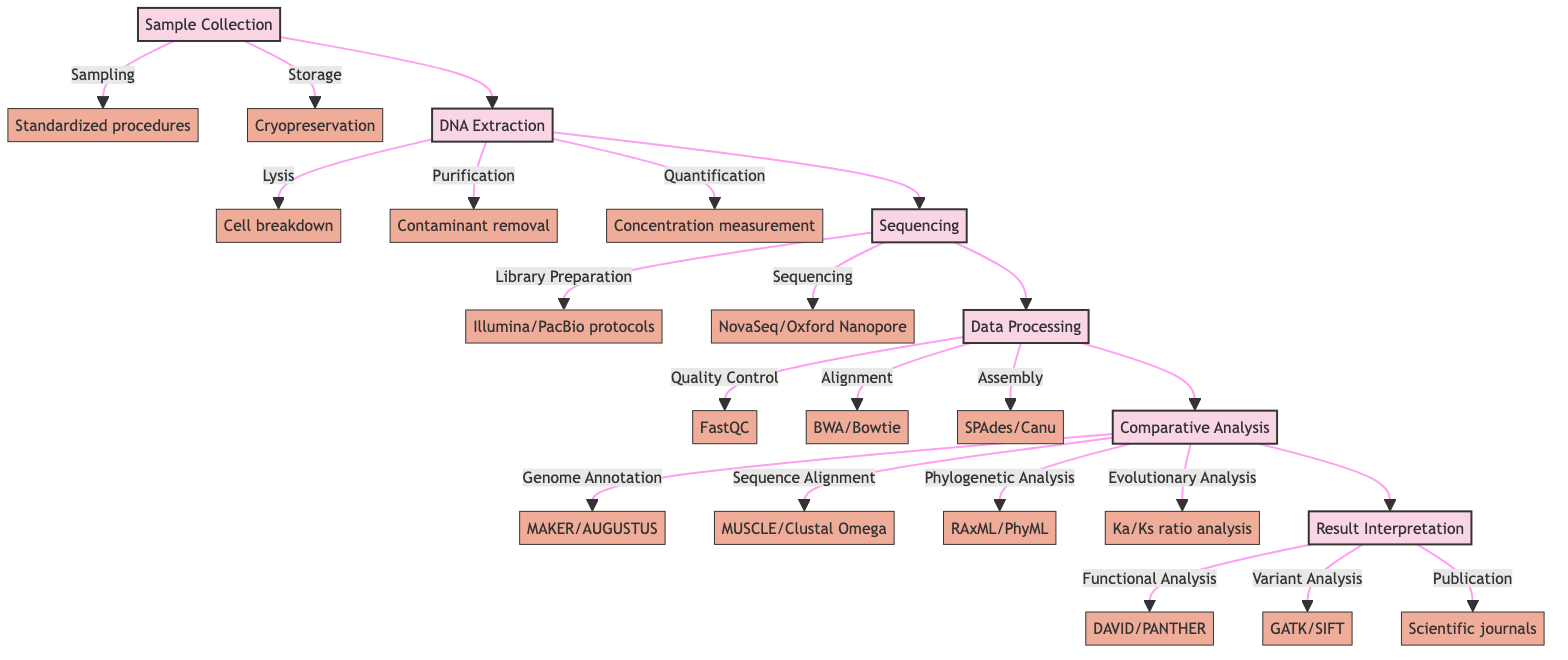What is the first stage of the workflow? The diagram starts with the "Sample Collection" stage, which is the initial step in the comparative genomic analysis workflow.
Answer: Sample Collection How many components are there in the Data Processing stage? The Data Processing stage consists of three components: Quality Control, Alignment, and Assembly, which can be counted directly from the diagram's listed components.
Answer: 3 What follows DNA Extraction in the workflow? The workflow proceeds from DNA Extraction to Sequencing, indicating that Sequencing is the next stage after DNA Extraction based on the flow connection in the diagram.
Answer: Sequencing Which tool is used for quality control during Data Processing? The diagram specifies "FastQC" as the tool used for quality control, which is clearly labeled in the Data Processing section.
Answer: FastQC What is the last stage in the workflow? The final stage is labeled as "Result Interpretation," indicating that this is where the results of the analysis are interpreted and conclusions are drawn.
Answer: Result Interpretation What are the tools used for phylogenetic analysis in the Comparative Analysis stage? According to the diagram, the tools listed for phylogenetic analysis are "RAxML" and "PhyML," which are shown as components in the Comparative Analysis stage.
Answer: RAxML/PhyML Which stage has the highest number of components? The Comparative Analysis stage has four components: Genome Annotation, Sequence Alignment, Phylogenetic Analysis, and Evolutionary Analysis, which is more than any other stage's components.
Answer: Comparative Analysis What is the last component listed under Result Interpretation? The last component in the Result Interpretation stage is "Publication," which signifies the end of the workflow.
Answer: Publication What is the main purpose of the Comparative Analysis stage? The Comparative Analysis stage focuses on comparing genomic sequences to identify similarities and differences between different mammalian species, as described in the workflow.
Answer: Compare genomic sequences 